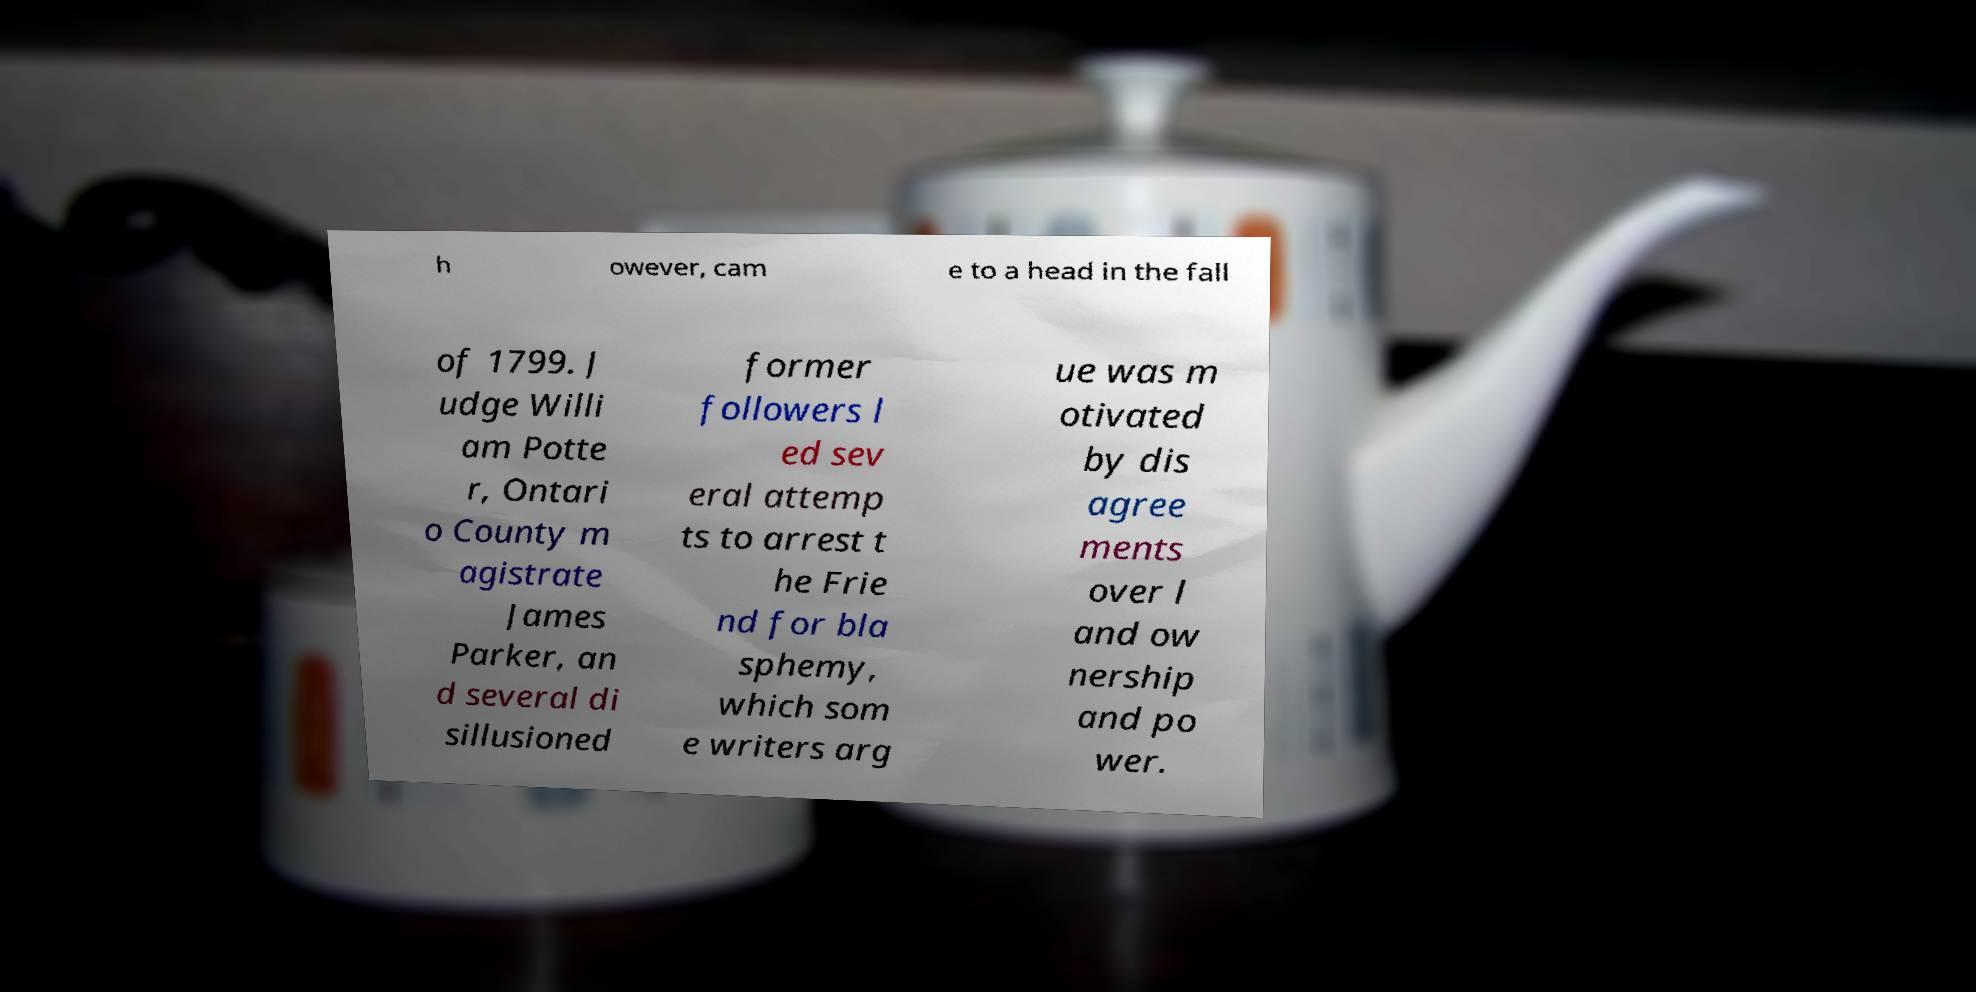Could you extract and type out the text from this image? h owever, cam e to a head in the fall of 1799. J udge Willi am Potte r, Ontari o County m agistrate James Parker, an d several di sillusioned former followers l ed sev eral attemp ts to arrest t he Frie nd for bla sphemy, which som e writers arg ue was m otivated by dis agree ments over l and ow nership and po wer. 